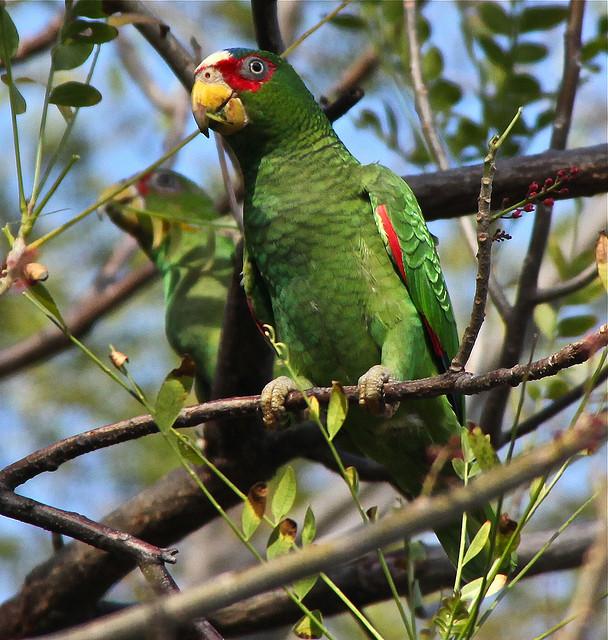Are the birds inside or outside?
Quick response, please. Outside. What color are these parrots?
Be succinct. Green. What do the birds sit on?
Be succinct. Branches. What color is the bird's beak?
Keep it brief. Yellow. Can these birds be taught to speak?
Concise answer only. Yes. Does this bird live where it snows?
Write a very short answer. No. 